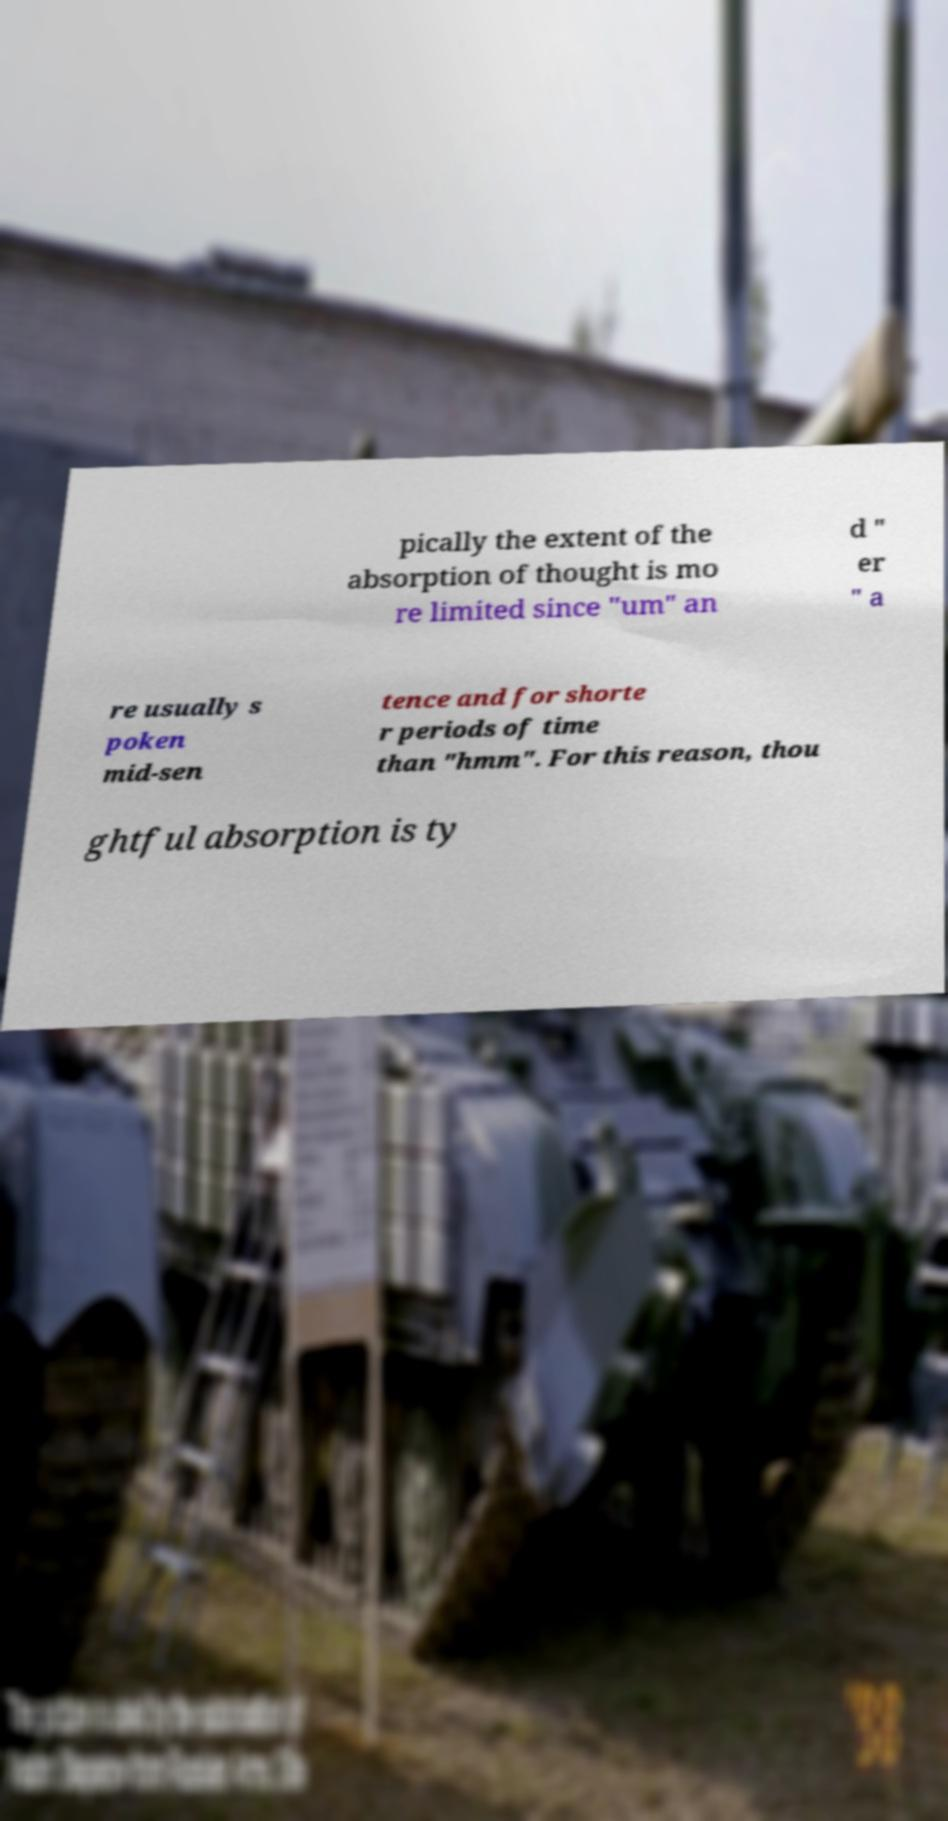Could you extract and type out the text from this image? pically the extent of the absorption of thought is mo re limited since "um" an d " er " a re usually s poken mid-sen tence and for shorte r periods of time than "hmm". For this reason, thou ghtful absorption is ty 